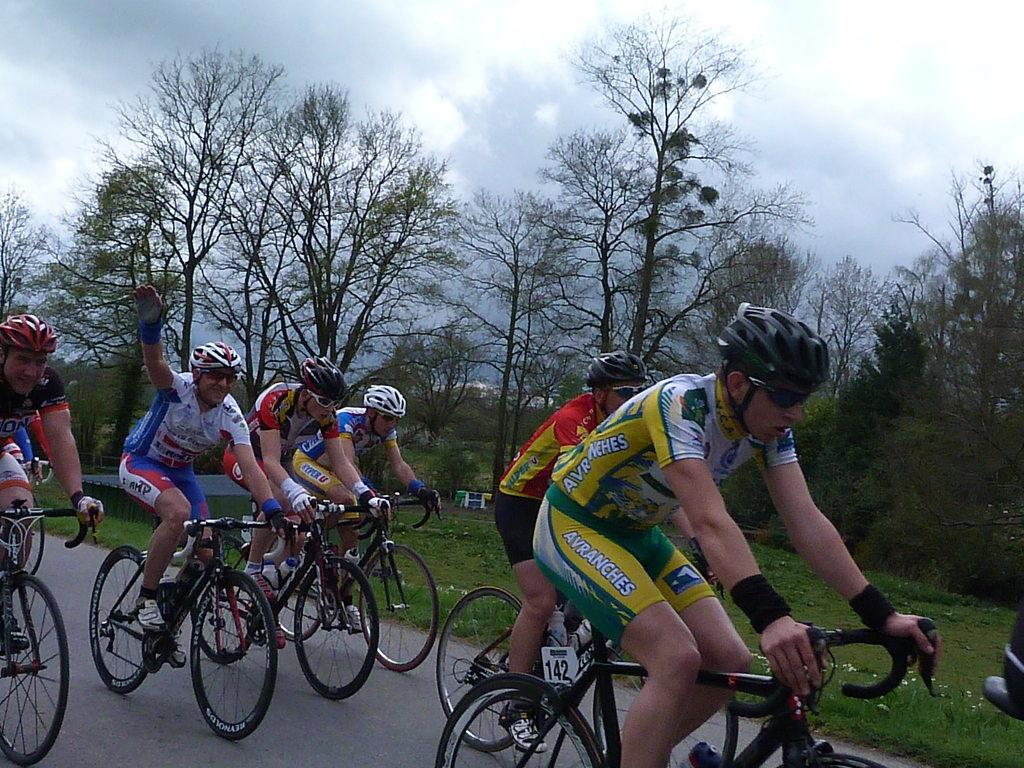What are the people in the image doing? The people in the image are riding bicycles. What type of terrain can be seen in the image? There is grass visible in the image. What other natural elements are present in the image? There are trees in the image. What type of mask is the beetle wearing in the image? There is no beetle present in the image, and therefore no mask can be observed. 